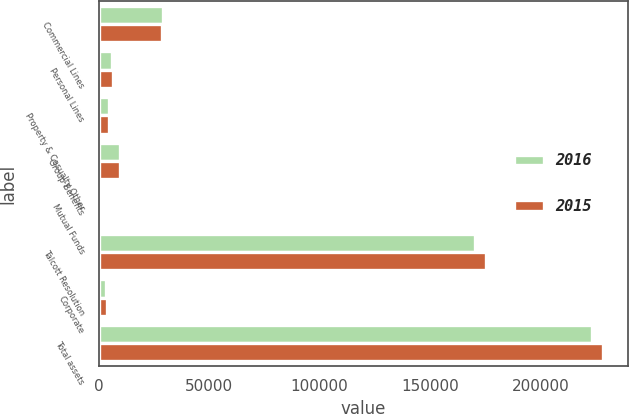Convert chart to OTSL. <chart><loc_0><loc_0><loc_500><loc_500><stacked_bar_chart><ecel><fcel>Commercial Lines<fcel>Personal Lines<fcel>Property & Casualty Other<fcel>Group Benefits<fcel>Mutual Funds<fcel>Talcott Resolution<fcel>Corporate<fcel>Total assets<nl><fcel>2016<fcel>29141<fcel>6083<fcel>4732<fcel>9405<fcel>480<fcel>170327<fcel>3264<fcel>223432<nl><fcel>2015<fcel>28388<fcel>6147<fcel>4562<fcel>9666<fcel>449<fcel>175319<fcel>3817<fcel>228348<nl></chart> 